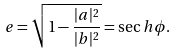Convert formula to latex. <formula><loc_0><loc_0><loc_500><loc_500>e = \sqrt { 1 - \frac { | a | ^ { 2 } } { | b | ^ { 2 } } } = \sec h \phi .</formula> 